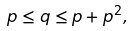Convert formula to latex. <formula><loc_0><loc_0><loc_500><loc_500>p \leq q \leq p + p ^ { 2 } ,</formula> 